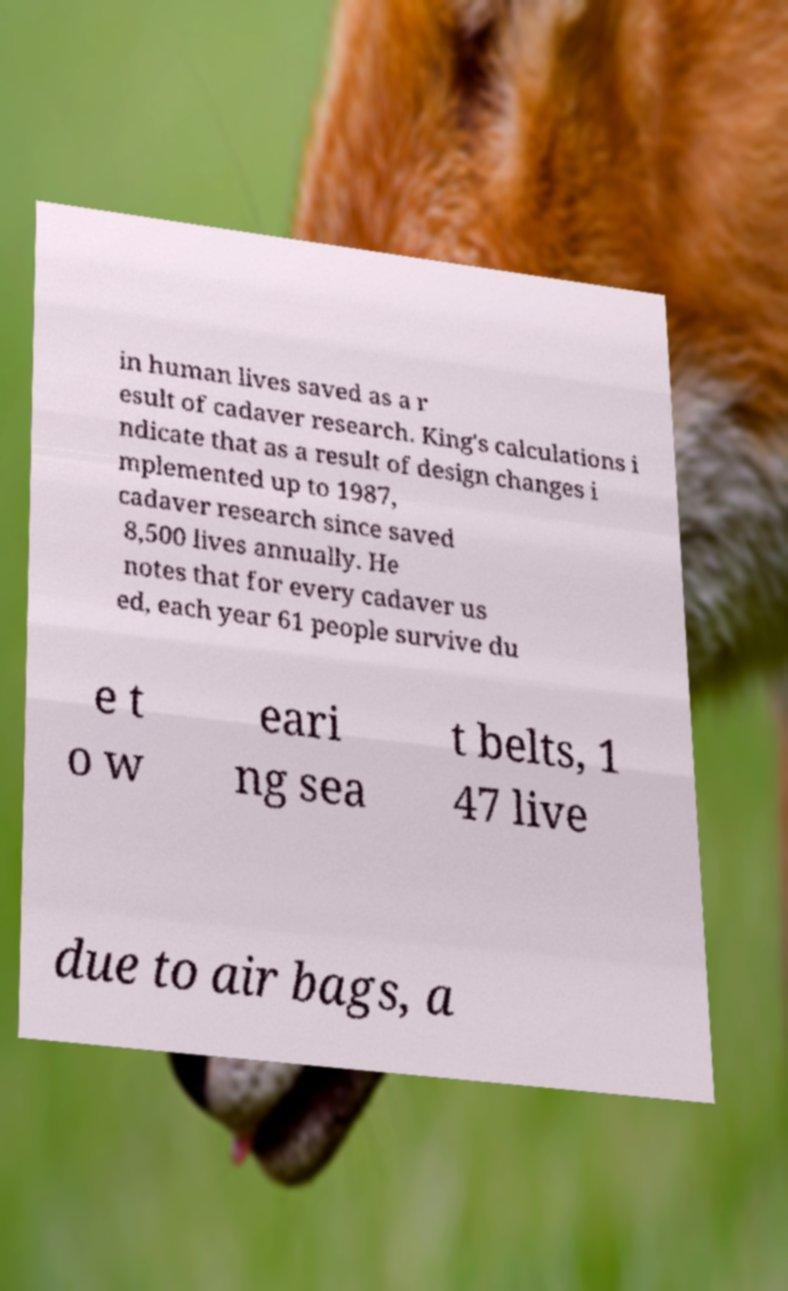Can you accurately transcribe the text from the provided image for me? in human lives saved as a r esult of cadaver research. King's calculations i ndicate that as a result of design changes i mplemented up to 1987, cadaver research since saved 8,500 lives annually. He notes that for every cadaver us ed, each year 61 people survive du e t o w eari ng sea t belts, 1 47 live due to air bags, a 